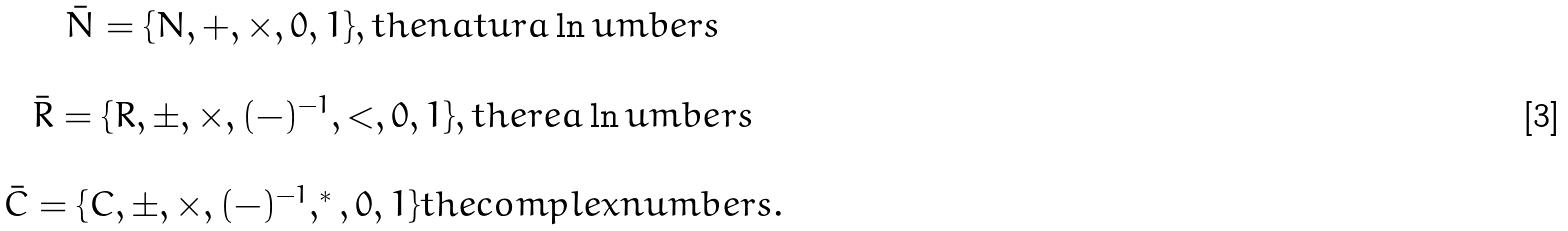<formula> <loc_0><loc_0><loc_500><loc_500>\begin{array} { c } \bar { N } = \{ N , + , \times , 0 , 1 \} , t h e n a t u r a \ln u m b e r s \\ \\ \bar { R } = \{ R , \pm , \times , ( - ) ^ { - 1 } , < , 0 , 1 \} , t h e r e a \ln u m b e r s \\ \\ \bar { C } = \{ C , \pm , \times , ( - ) ^ { - 1 } , ^ { * } , 0 , 1 \} t h e c o m p l e x n u m b e r s . \end{array}</formula> 